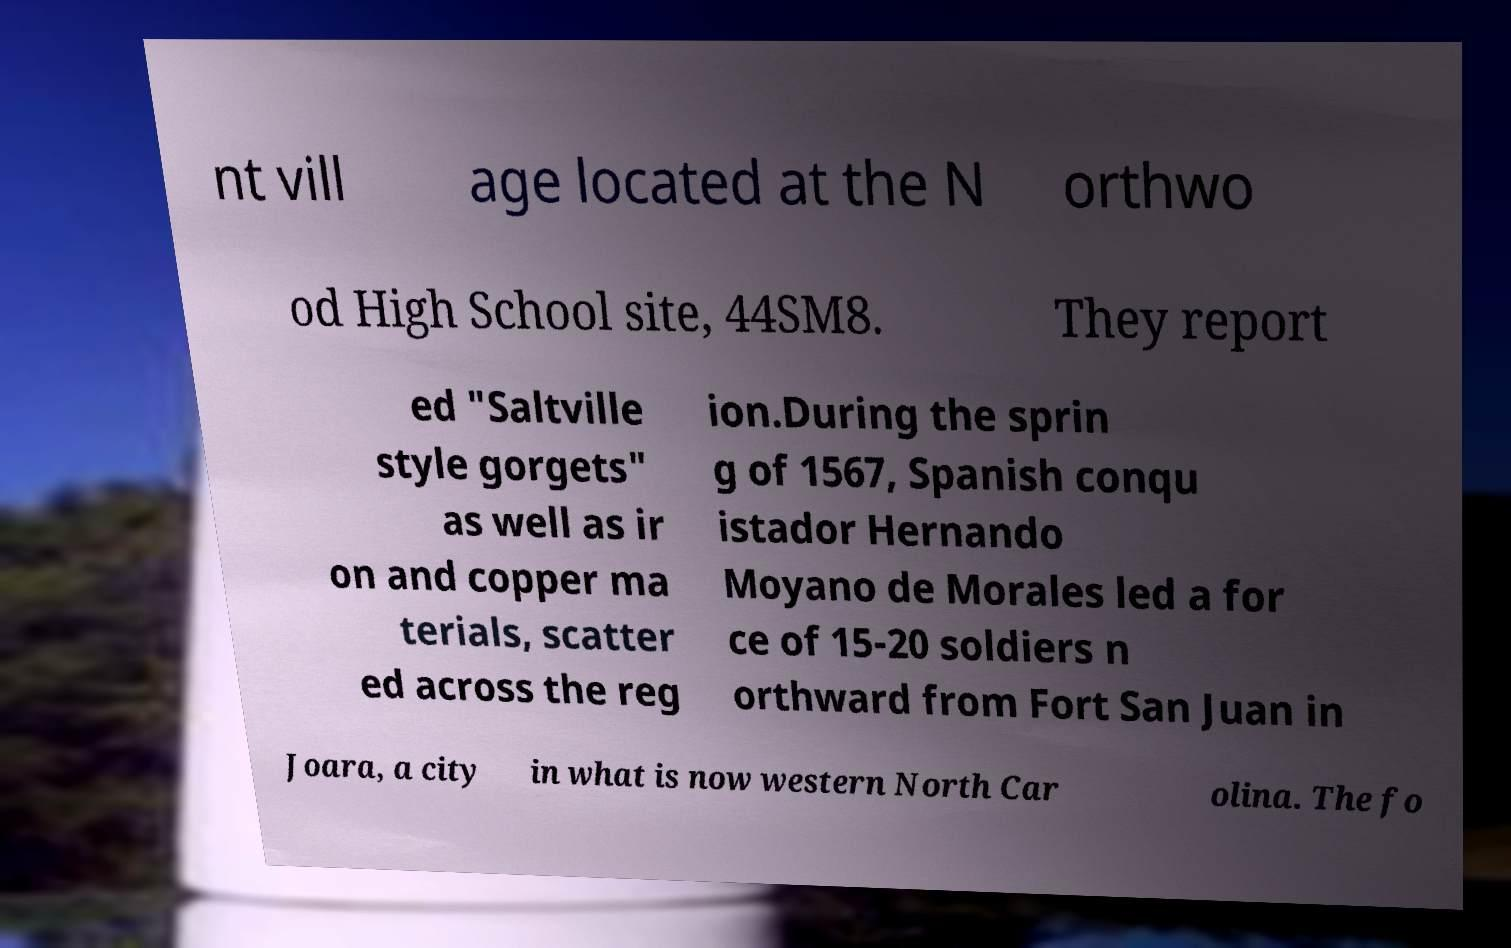Can you read and provide the text displayed in the image?This photo seems to have some interesting text. Can you extract and type it out for me? nt vill age located at the N orthwo od High School site, 44SM8. They report ed "Saltville style gorgets" as well as ir on and copper ma terials, scatter ed across the reg ion.During the sprin g of 1567, Spanish conqu istador Hernando Moyano de Morales led a for ce of 15-20 soldiers n orthward from Fort San Juan in Joara, a city in what is now western North Car olina. The fo 